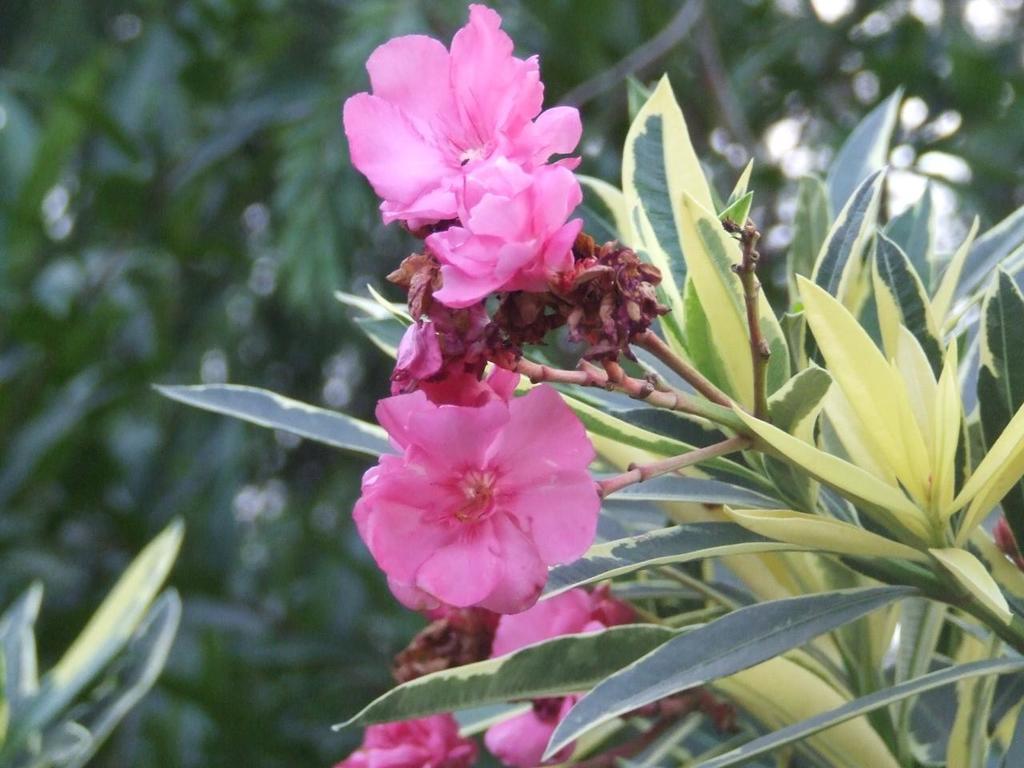How would you summarize this image in a sentence or two? In this image I can see a plant which is green in color and to it I can see few flowers which are pink in color. In the background I can see few trees which are green in color. 